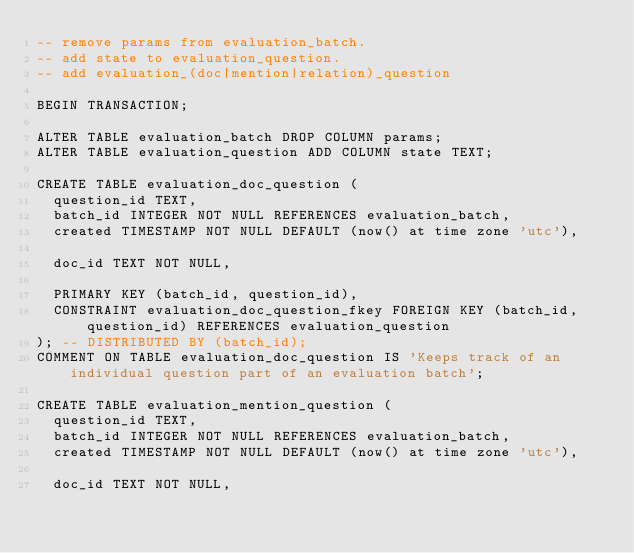<code> <loc_0><loc_0><loc_500><loc_500><_SQL_>-- remove params from evaluation_batch.
-- add state to evaluation_question.
-- add evaluation_(doc|mention|relation)_question

BEGIN TRANSACTION;

ALTER TABLE evaluation_batch DROP COLUMN params;
ALTER TABLE evaluation_question ADD COLUMN state TEXT;

CREATE TABLE evaluation_doc_question (
  question_id TEXT, 
  batch_id INTEGER NOT NULL REFERENCES evaluation_batch,
  created TIMESTAMP NOT NULL DEFAULT (now() at time zone 'utc'),

  doc_id TEXT NOT NULL,

  PRIMARY KEY (batch_id, question_id),
  CONSTRAINT evaluation_doc_question_fkey FOREIGN KEY (batch_id, question_id) REFERENCES evaluation_question
); -- DISTRIBUTED BY (batch_id);
COMMENT ON TABLE evaluation_doc_question IS 'Keeps track of an individual question part of an evaluation batch';

CREATE TABLE evaluation_mention_question (
  question_id TEXT, 
  batch_id INTEGER NOT NULL REFERENCES evaluation_batch,
  created TIMESTAMP NOT NULL DEFAULT (now() at time zone 'utc'),

  doc_id TEXT NOT NULL,</code> 